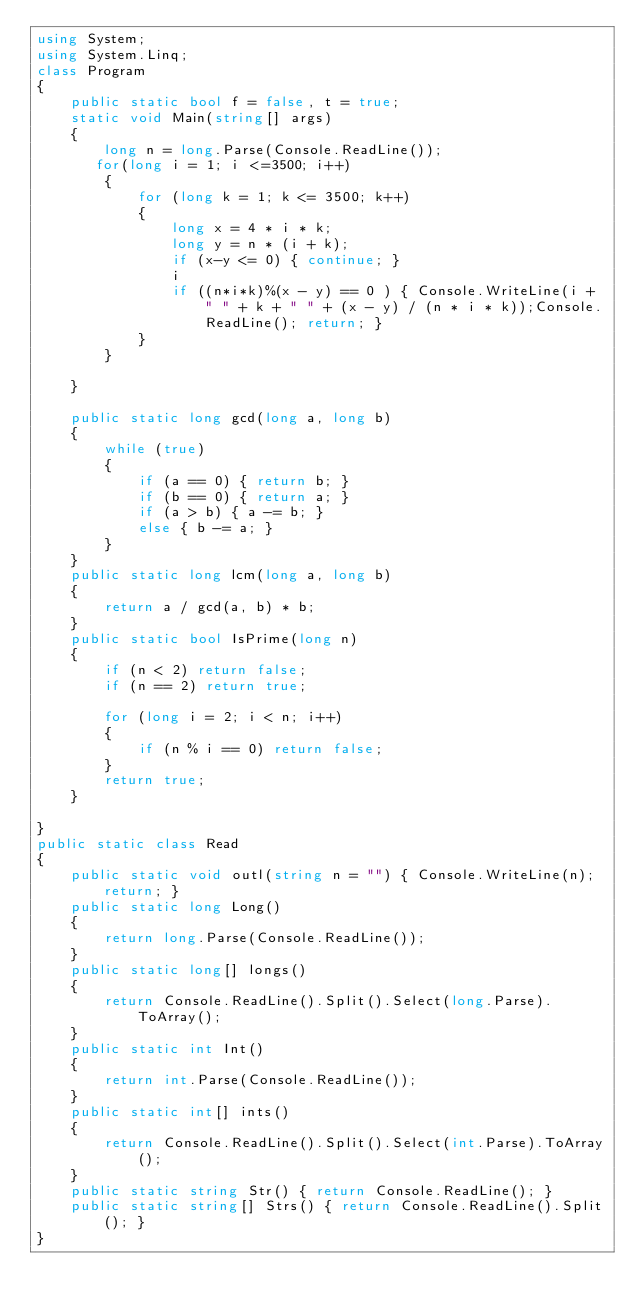<code> <loc_0><loc_0><loc_500><loc_500><_C#_>using System;
using System.Linq;
class Program
{
    public static bool f = false, t = true;
    static void Main(string[] args)
    {
        long n = long.Parse(Console.ReadLine());
       for(long i = 1; i <=3500; i++)
        {
            for (long k = 1; k <= 3500; k++)
            {
                long x = 4 * i * k;
                long y = n * (i + k);
                if (x-y <= 0) { continue; }
                i
                if ((n*i*k)%(x - y) == 0 ) { Console.WriteLine(i + " " + k + " " + (x - y) / (n * i * k));Console.ReadLine(); return; }
            }
        }

    }

    public static long gcd(long a, long b)
    {
        while (true)
        {
            if (a == 0) { return b; }
            if (b == 0) { return a; }
            if (a > b) { a -= b; }
            else { b -= a; }
        }
    }
    public static long lcm(long a, long b)
    {
        return a / gcd(a, b) * b;
    }
    public static bool IsPrime(long n)
    {
        if (n < 2) return false;
        if (n == 2) return true;

        for (long i = 2; i < n; i++)
        {
            if (n % i == 0) return false;
        }
        return true;
    }

}
public static class Read
{
    public static void outl(string n = "") { Console.WriteLine(n); return; }
    public static long Long()
    {
        return long.Parse(Console.ReadLine());
    }
    public static long[] longs()
    {
        return Console.ReadLine().Split().Select(long.Parse).ToArray();
    }
    public static int Int()
    {
        return int.Parse(Console.ReadLine());
    }
    public static int[] ints()
    {
        return Console.ReadLine().Split().Select(int.Parse).ToArray();
    }
    public static string Str() { return Console.ReadLine(); }
    public static string[] Strs() { return Console.ReadLine().Split(); }
}</code> 